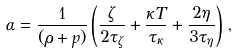Convert formula to latex. <formula><loc_0><loc_0><loc_500><loc_500>\alpha = \frac { 1 } { ( \rho + p ) } \left ( \frac { \zeta } { 2 \tau _ { \zeta } } + \frac { \kappa T } { \tau _ { \kappa } } + \frac { 2 \eta } { 3 \tau _ { \eta } } \right ) \, ,</formula> 